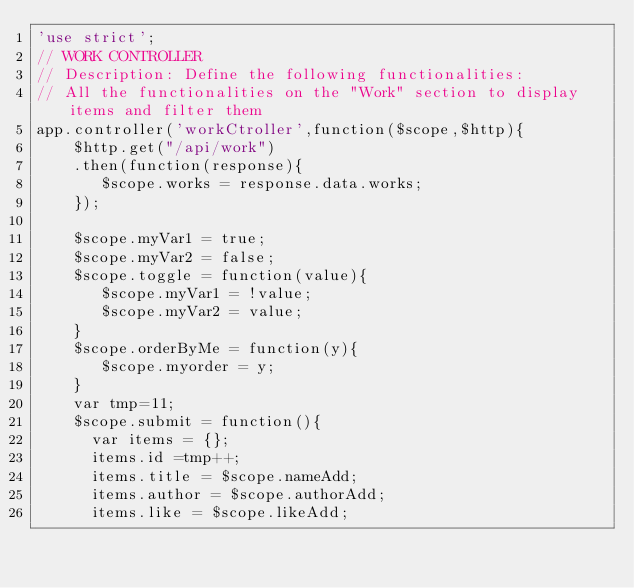<code> <loc_0><loc_0><loc_500><loc_500><_JavaScript_>'use strict';
// WORK CONTROLLER
// Description: Define the following functionalities:
// All the functionalities on the "Work" section to display items and filter them
app.controller('workCtroller',function($scope,$http){
    $http.get("/api/work")
    .then(function(response){
       $scope.works = response.data.works;
    });

    $scope.myVar1 = true;
    $scope.myVar2 = false;
    $scope.toggle = function(value){
       $scope.myVar1 = !value;
       $scope.myVar2 = value;
    }
    $scope.orderByMe = function(y){
       $scope.myorder = y;
    }
    var tmp=11;
    $scope.submit = function(){
      var items = {};
      items.id =tmp++;
      items.title = $scope.nameAdd;
      items.author = $scope.authorAdd;
      items.like = $scope.likeAdd;</code> 